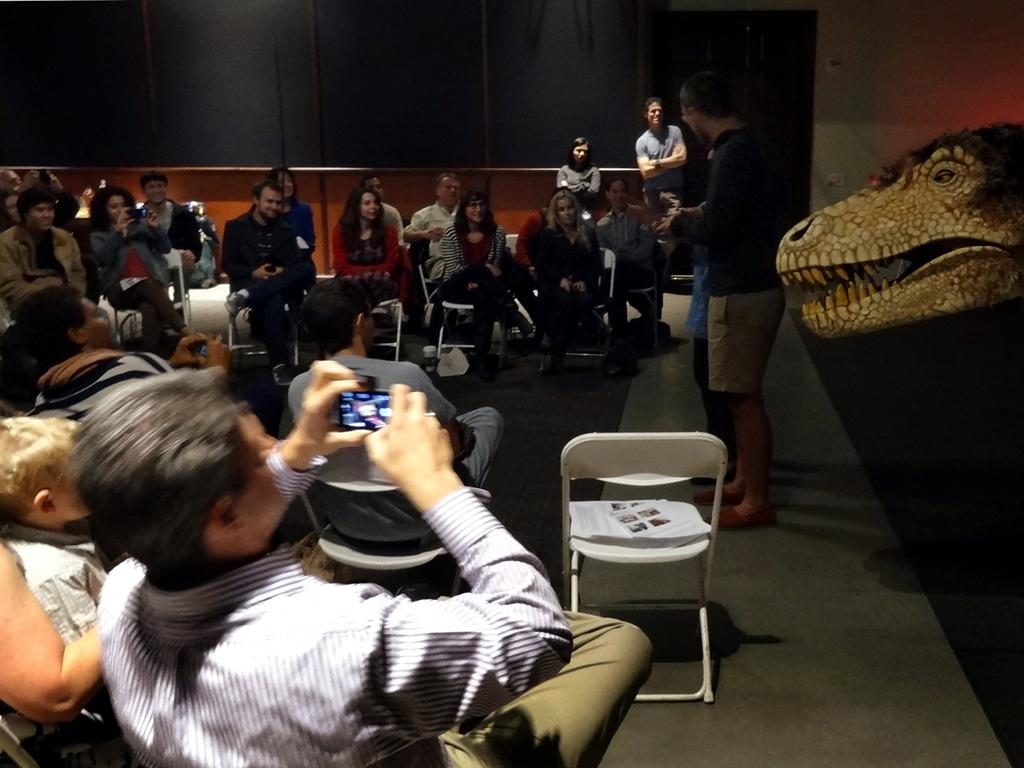What is happening in the image involving a group of people? There is a group of people sitting in a chair in the image. Can you describe the activity of one of the individuals in the image? A man is holding a camera in the image. What can be seen in the background of the image? There is a wall in the background of the image. What type of grain is being harvested by the snails in the image? There are no snails or grain present in the image. How many wheels can be seen on the chair in the image? The chair in the image does not have any visible wheels. 